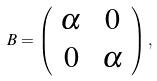<formula> <loc_0><loc_0><loc_500><loc_500>B = \left ( \begin{array} { c c } \alpha & \, 0 \\ 0 & \, \alpha \end{array} \right ) ,</formula> 